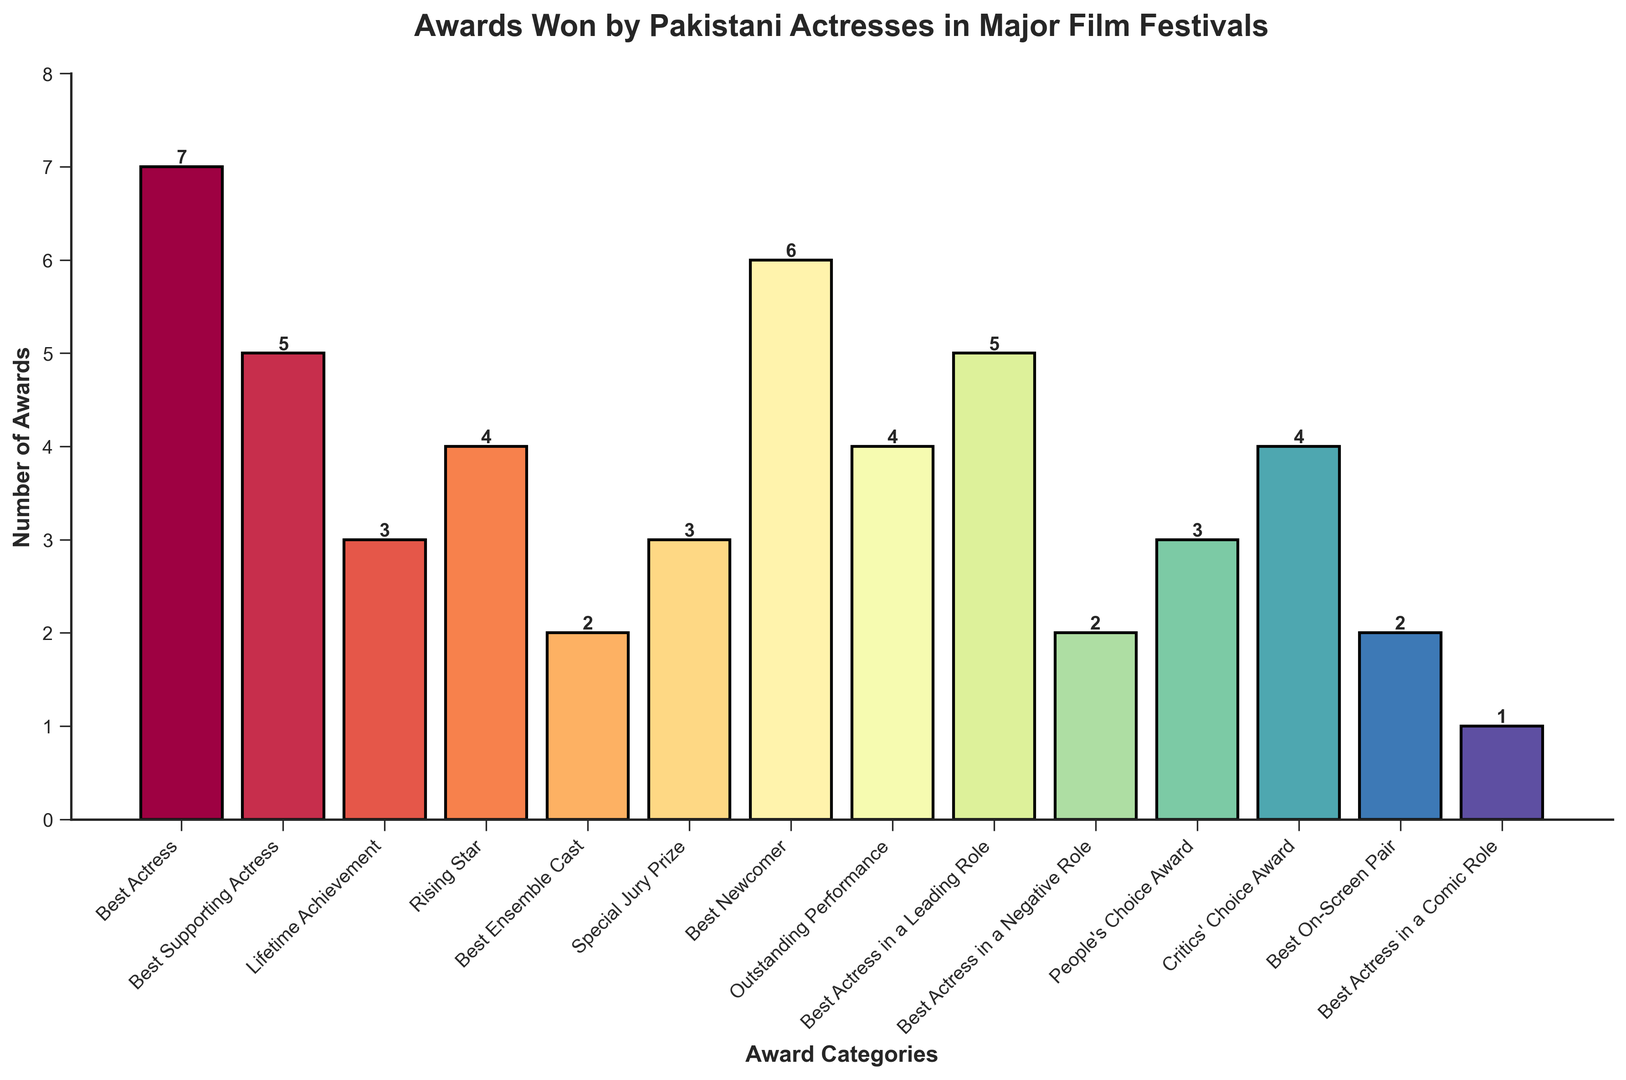What's the most awarded category? Examine the heights of all the bars representing each category. The category with the highest bar indicates the highest number of awards.
Answer: Best Actress Which category has more awards: Critics' Choice Award or People's Choice Award? Compare the heights of the bars corresponding to Critics' Choice Award and People's Choice Award. The Critics' Choice Award bar is higher.
Answer: Critics' Choice Award How many total awards were given across all categories? Add the number of awards from each category: 7 + 5 + 3 + 4 + 2 + 3 + 6 + 4 + 5 + 2 + 3 + 4 + 2 + 1 = 51
Answer: 51 What is the difference in awards between the Best Actress and Best Actress in a Leading Role categories? Subtract the number of awards of Best Actress in a Leading Role (5) from Best Actress (7): 7 - 5 = 2
Answer: 2 Which has fewer awards: Best Newcomer or Best Supporting Actress? Compare the heights of the bars for Best Newcomer and Best Supporting Actress. Best Supporting Actress is lower.
Answer: Best Supporting Actress What is the average number of awards per category? To find the average, divide the total number of awards (51) by the number of categories (14): 51 / 14 ≈ 3.64
Answer: 3.64 Are there more awards in the Best Ensemble Cast or Best On-Screen Pair categories? Look at the bars for Best Ensemble Cast and Best On-Screen Pair. They have the same height.
Answer: They are equal Which categories have exactly 3 awards? Identify bars with a height of 3: Lifetime Achievement, Special Jury Prize, and People's Choice Award.
Answer: Lifetime Achievement, Special Jury Prize, People's Choice Award How many categories have more than 4 awards? Count the number of bars with a height greater than 4: Best Actress, Best Newcomer.
Answer: 2 